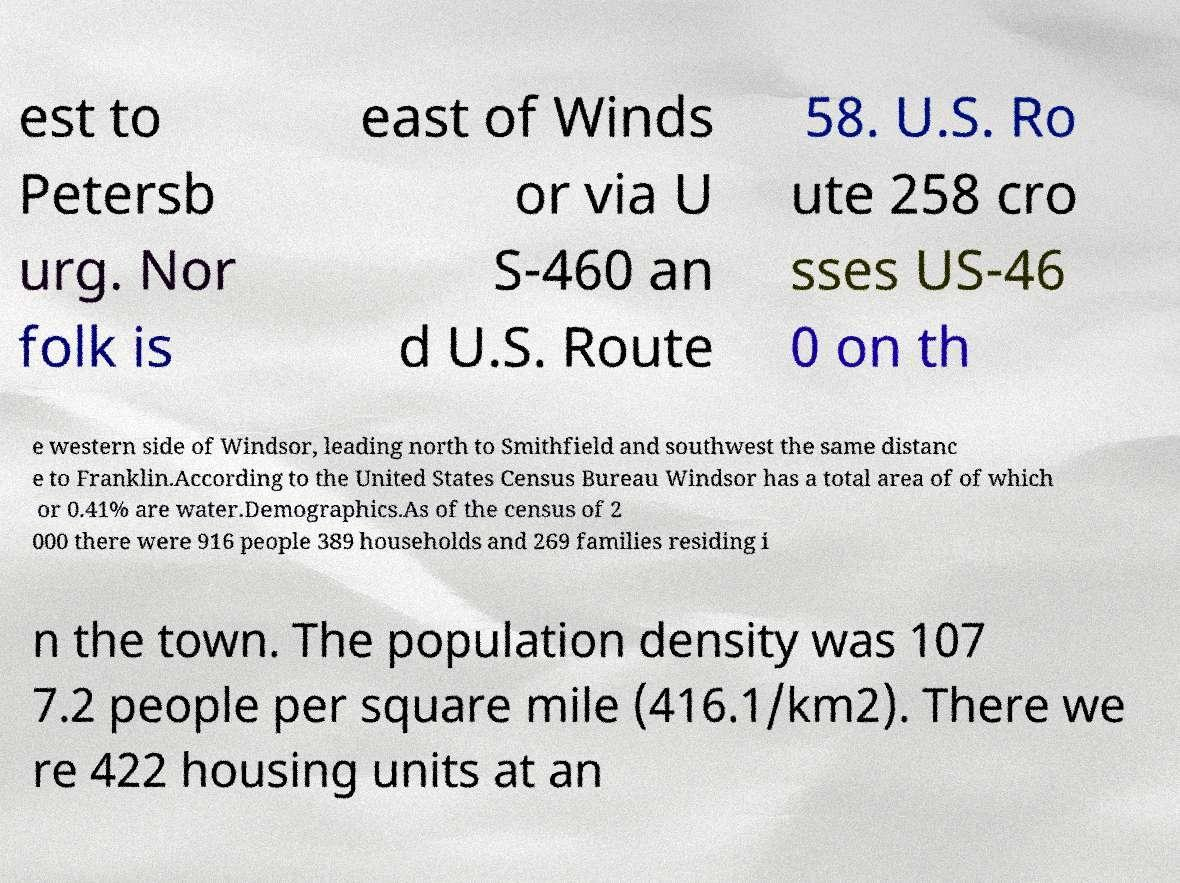Can you accurately transcribe the text from the provided image for me? est to Petersb urg. Nor folk is east of Winds or via U S-460 an d U.S. Route 58. U.S. Ro ute 258 cro sses US-46 0 on th e western side of Windsor, leading north to Smithfield and southwest the same distanc e to Franklin.According to the United States Census Bureau Windsor has a total area of of which or 0.41% are water.Demographics.As of the census of 2 000 there were 916 people 389 households and 269 families residing i n the town. The population density was 107 7.2 people per square mile (416.1/km2). There we re 422 housing units at an 